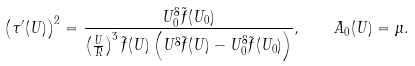<formula> <loc_0><loc_0><loc_500><loc_500>\left ( \tau ^ { \prime } ( U ) \right ) ^ { 2 } = \frac { U _ { 0 } ^ { 8 } \tilde { f } ( U _ { 0 } ) } { \left ( \frac { U } { R } \right ) ^ { 3 } \tilde { f } ( U ) \left ( U ^ { 8 } \tilde { f } ( U ) - U _ { 0 } ^ { 8 } \tilde { f } ( U _ { 0 } ) \right ) } , \quad A _ { 0 } ( U ) = \mu .</formula> 